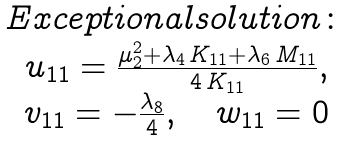<formula> <loc_0><loc_0><loc_500><loc_500>\begin{matrix} E x c e p t i o n a l s o l u t i o n \colon \\ u _ { 1 1 } = \frac { \mu _ { 2 } ^ { 2 } + \lambda _ { 4 } \, K _ { 1 1 } + \lambda _ { 6 } \, M _ { 1 1 } } { 4 \, K _ { 1 1 } } , \\ v _ { 1 1 } = - \frac { \lambda _ { 8 } } { 4 } , \quad w _ { 1 1 } = 0 \end{matrix}</formula> 